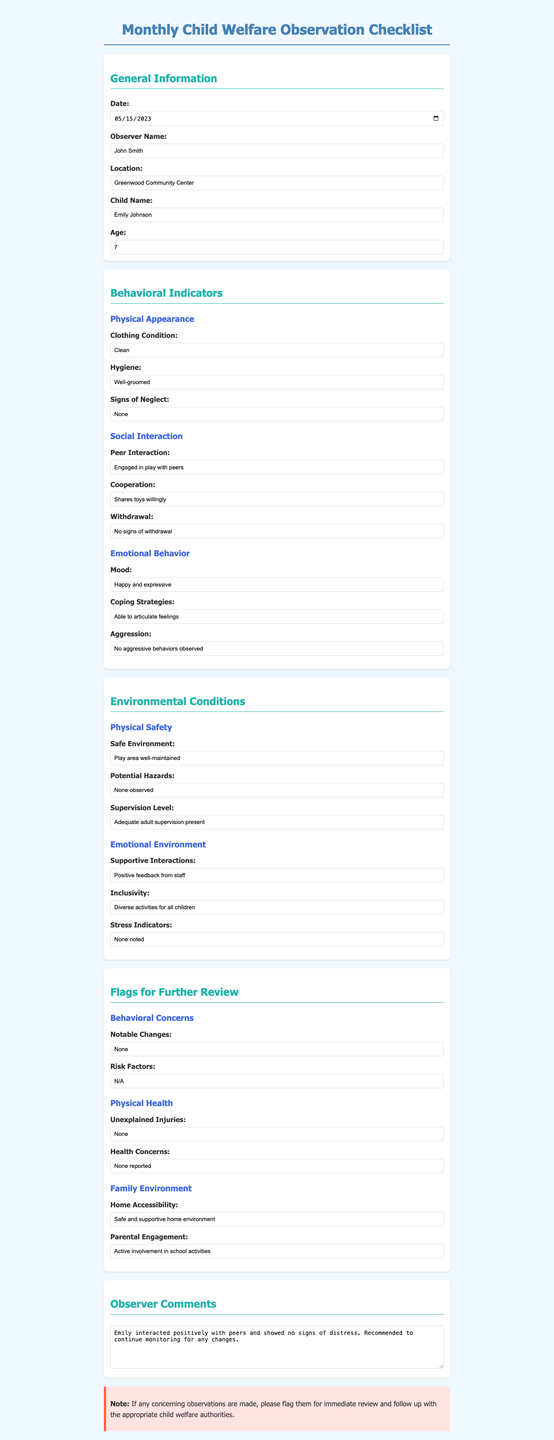What is the date of the observation? The date of the observation is provided in the General Information section of the document.
Answer: 2023-05-15 Who is the observer? The observer's name is listed under General Information in the document.
Answer: John Smith What is the child's name? The child's name is included in the General Information section of the document.
Answer: Emily Johnson How old is the child? The child's age is specified in the General Information section.
Answer: 7 What was the mood of the child during the observation? The mood is indicated in the Emotional Behavior subsection of the Behavioral Indicators section.
Answer: Happy and expressive What type of environment is indicated for the child’s home? The home environment is noted in the Flags for Further Review section regarding family environment.
Answer: Safe and supportive home environment Was there any indication of unexplained injuries? The health section under Flags for Further Review shows this information.
Answer: None Were there any notable changes observed? This is specified in the Flags for Further Review section under Behavioral Concerns.
Answer: None What were the child's coping strategies? The coping strategies can be found in the Emotional Behavior subsection of the Behavioral Indicators section.
Answer: Able to articulate feelings 